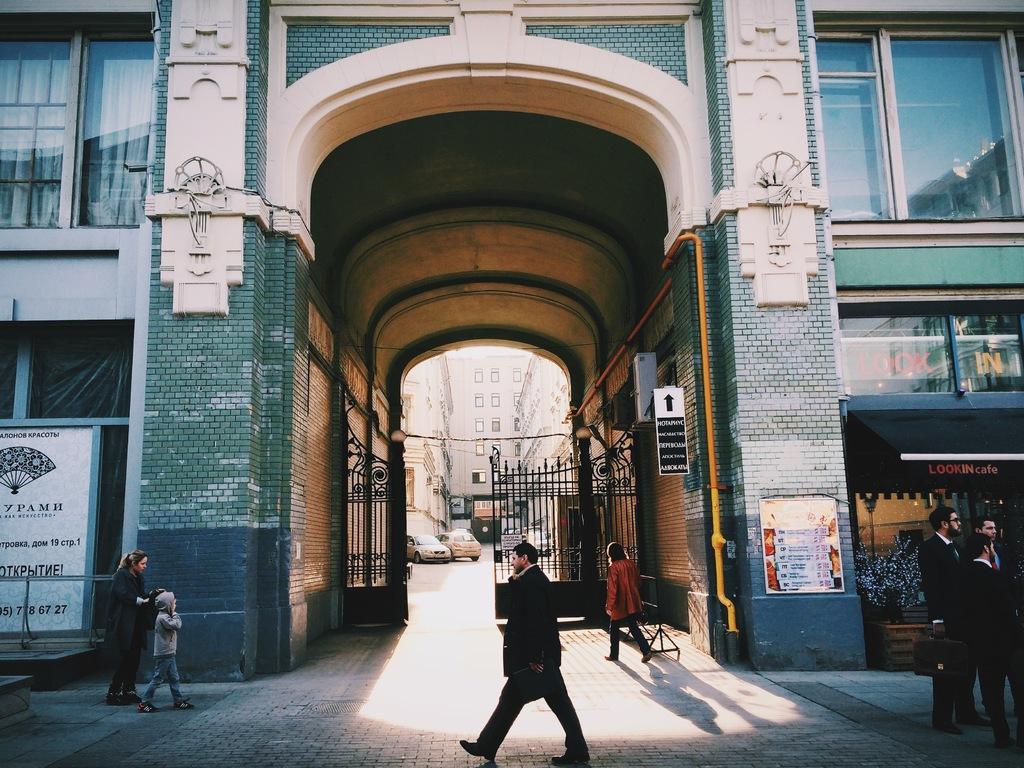In one or two sentences, can you explain what this image depicts? In this picture we can observe some people walking and some of them were standing. There is a building. We can observe a gate here. There are two cars. In the background there are some buildings. 